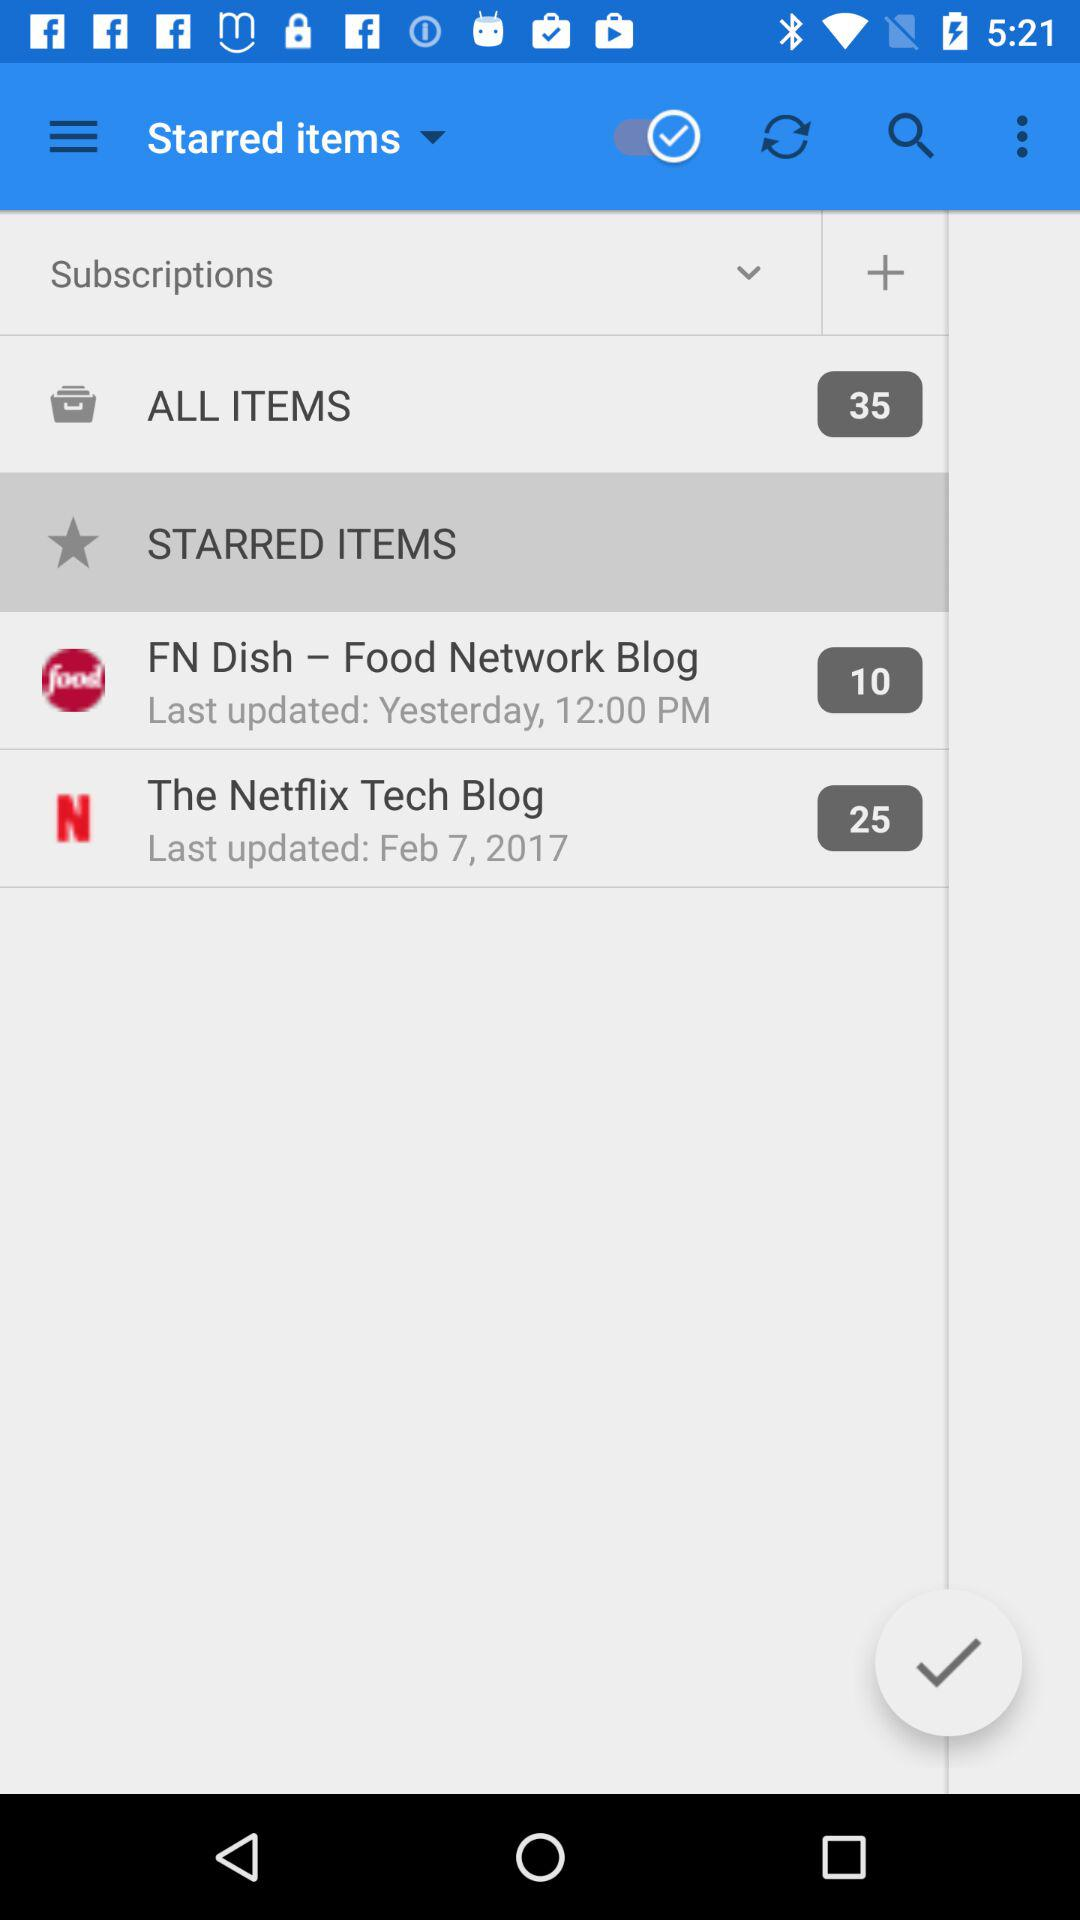How many stars are given Netflix Tech blog?
When the provided information is insufficient, respond with <no answer>. <no answer> 